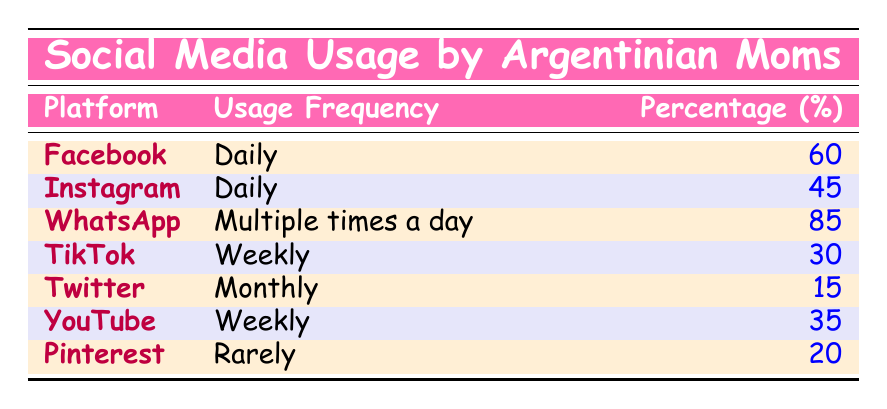What percentage of Argentinian moms use Facebook daily? The table indicates that the percentage of Argentinian moms using Facebook daily is stated right next to the platform in the "Percentage (%)" column. It shows 60% for Facebook.
Answer: 60% Which social media platform has the highest usage frequency among Argentinian moms? The table lists the platforms and their respective usage frequencies. WhatsApp has the highest percentage shown as "Multiple times a day" with 85%.
Answer: WhatsApp How many more moms use WhatsApp multiple times a day compared to Twitter monthly? The percentage of moms using WhatsApp multiple times a day is 85%, and those using Twitter monthly is 15%. The difference is calculated as 85 - 15 = 70.
Answer: 70 Is TikTok used more frequently than Pinterest by Argentinian moms? Comparing the frequencies in the table, TikTok has 30% usage while Pinterest has 20%. Therefore, TikTok is used more frequently than Pinterest.
Answer: Yes What is the average percentage of usage frequency for platforms that are used weekly? To find the average, we first identify the platforms with weekly usage: TikTok (30%) and YouTube (35%). Their sum is 30 + 35 = 65, and since there are 2 platforms, the average is 65/2 = 32.5.
Answer: 32.5 How many platforms are used daily by Argentinian moms? By reviewing the table, both Facebook and Instagram are shown as daily platforms. There are 2 platforms listed under "Daily."
Answer: 2 Which platform has the lowest usage percentage among Argentinian moms? By observing the percentages, Twitter has the lowest at 15%. This is confirmed by comparing all listed platforms.
Answer: Twitter What is the total percentage of moms using social media daily? The daily usage platforms are Facebook (60%) and Instagram (45%). Adding these gives a total of 60 + 45 = 105%.
Answer: 105% How many more moms use Instagram daily than TikTok weekly? The percentage of moms using Instagram daily is 45%, while TikTok weekly is 30%. The difference calculated is 45 - 30 = 15.
Answer: 15 